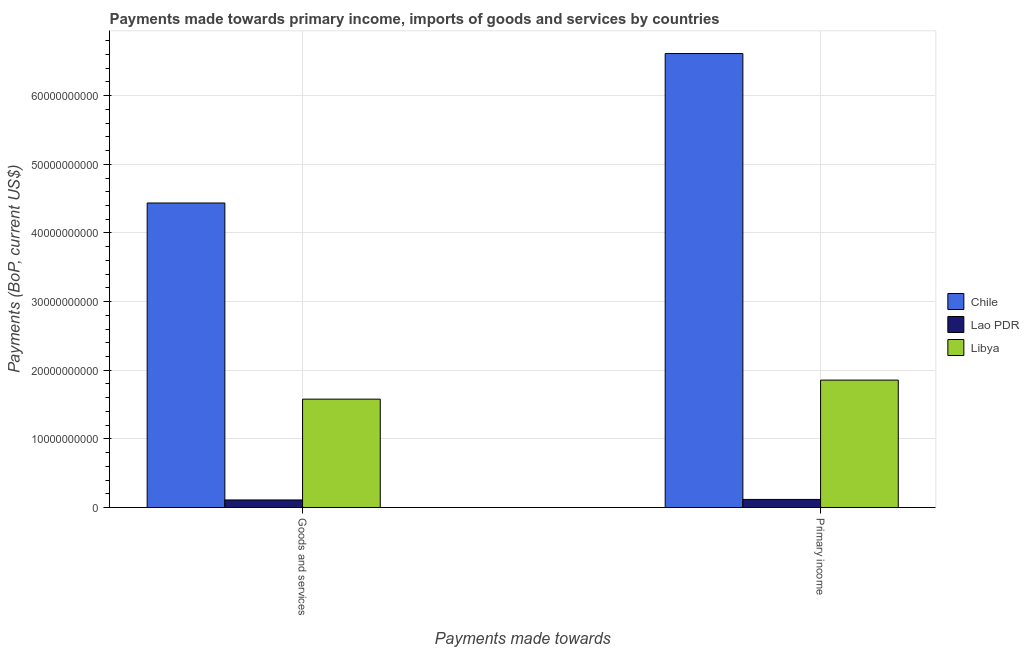How many different coloured bars are there?
Provide a succinct answer. 3. How many groups of bars are there?
Provide a succinct answer. 2. Are the number of bars per tick equal to the number of legend labels?
Give a very brief answer. Yes. What is the label of the 2nd group of bars from the left?
Offer a terse response. Primary income. What is the payments made towards goods and services in Lao PDR?
Offer a very short reply. 1.10e+09. Across all countries, what is the maximum payments made towards goods and services?
Offer a very short reply. 4.44e+1. Across all countries, what is the minimum payments made towards goods and services?
Provide a short and direct response. 1.10e+09. In which country was the payments made towards primary income minimum?
Keep it short and to the point. Lao PDR. What is the total payments made towards primary income in the graph?
Provide a short and direct response. 8.59e+1. What is the difference between the payments made towards primary income in Libya and that in Lao PDR?
Offer a very short reply. 1.74e+1. What is the difference between the payments made towards goods and services in Libya and the payments made towards primary income in Lao PDR?
Your answer should be very brief. 1.46e+1. What is the average payments made towards primary income per country?
Your answer should be very brief. 2.86e+1. What is the difference between the payments made towards goods and services and payments made towards primary income in Libya?
Ensure brevity in your answer.  -2.78e+09. What is the ratio of the payments made towards goods and services in Lao PDR to that in Libya?
Provide a succinct answer. 0.07. In how many countries, is the payments made towards primary income greater than the average payments made towards primary income taken over all countries?
Your answer should be compact. 1. What does the 1st bar from the left in Goods and services represents?
Offer a terse response. Chile. How many bars are there?
Provide a short and direct response. 6. Are all the bars in the graph horizontal?
Your answer should be very brief. No. Are the values on the major ticks of Y-axis written in scientific E-notation?
Make the answer very short. No. How many legend labels are there?
Your answer should be compact. 3. How are the legend labels stacked?
Your answer should be very brief. Vertical. What is the title of the graph?
Give a very brief answer. Payments made towards primary income, imports of goods and services by countries. What is the label or title of the X-axis?
Your answer should be very brief. Payments made towards. What is the label or title of the Y-axis?
Give a very brief answer. Payments (BoP, current US$). What is the Payments (BoP, current US$) in Chile in Goods and services?
Your answer should be compact. 4.44e+1. What is the Payments (BoP, current US$) in Lao PDR in Goods and services?
Ensure brevity in your answer.  1.10e+09. What is the Payments (BoP, current US$) of Libya in Goods and services?
Your response must be concise. 1.58e+1. What is the Payments (BoP, current US$) in Chile in Primary income?
Offer a very short reply. 6.61e+1. What is the Payments (BoP, current US$) of Lao PDR in Primary income?
Give a very brief answer. 1.17e+09. What is the Payments (BoP, current US$) of Libya in Primary income?
Provide a succinct answer. 1.86e+1. Across all Payments made towards, what is the maximum Payments (BoP, current US$) in Chile?
Provide a succinct answer. 6.61e+1. Across all Payments made towards, what is the maximum Payments (BoP, current US$) in Lao PDR?
Ensure brevity in your answer.  1.17e+09. Across all Payments made towards, what is the maximum Payments (BoP, current US$) of Libya?
Offer a terse response. 1.86e+1. Across all Payments made towards, what is the minimum Payments (BoP, current US$) of Chile?
Keep it short and to the point. 4.44e+1. Across all Payments made towards, what is the minimum Payments (BoP, current US$) of Lao PDR?
Your response must be concise. 1.10e+09. Across all Payments made towards, what is the minimum Payments (BoP, current US$) in Libya?
Provide a short and direct response. 1.58e+1. What is the total Payments (BoP, current US$) of Chile in the graph?
Provide a succinct answer. 1.10e+11. What is the total Payments (BoP, current US$) in Lao PDR in the graph?
Provide a short and direct response. 2.27e+09. What is the total Payments (BoP, current US$) of Libya in the graph?
Ensure brevity in your answer.  3.43e+1. What is the difference between the Payments (BoP, current US$) of Chile in Goods and services and that in Primary income?
Offer a very short reply. -2.18e+1. What is the difference between the Payments (BoP, current US$) in Lao PDR in Goods and services and that in Primary income?
Offer a very short reply. -7.54e+07. What is the difference between the Payments (BoP, current US$) of Libya in Goods and services and that in Primary income?
Give a very brief answer. -2.78e+09. What is the difference between the Payments (BoP, current US$) of Chile in Goods and services and the Payments (BoP, current US$) of Lao PDR in Primary income?
Provide a succinct answer. 4.32e+1. What is the difference between the Payments (BoP, current US$) of Chile in Goods and services and the Payments (BoP, current US$) of Libya in Primary income?
Provide a short and direct response. 2.58e+1. What is the difference between the Payments (BoP, current US$) in Lao PDR in Goods and services and the Payments (BoP, current US$) in Libya in Primary income?
Make the answer very short. -1.75e+1. What is the average Payments (BoP, current US$) of Chile per Payments made towards?
Give a very brief answer. 5.52e+1. What is the average Payments (BoP, current US$) in Lao PDR per Payments made towards?
Keep it short and to the point. 1.14e+09. What is the average Payments (BoP, current US$) of Libya per Payments made towards?
Ensure brevity in your answer.  1.72e+1. What is the difference between the Payments (BoP, current US$) of Chile and Payments (BoP, current US$) of Lao PDR in Goods and services?
Offer a very short reply. 4.33e+1. What is the difference between the Payments (BoP, current US$) in Chile and Payments (BoP, current US$) in Libya in Goods and services?
Your response must be concise. 2.86e+1. What is the difference between the Payments (BoP, current US$) in Lao PDR and Payments (BoP, current US$) in Libya in Goods and services?
Offer a very short reply. -1.47e+1. What is the difference between the Payments (BoP, current US$) of Chile and Payments (BoP, current US$) of Lao PDR in Primary income?
Give a very brief answer. 6.50e+1. What is the difference between the Payments (BoP, current US$) of Chile and Payments (BoP, current US$) of Libya in Primary income?
Offer a very short reply. 4.76e+1. What is the difference between the Payments (BoP, current US$) in Lao PDR and Payments (BoP, current US$) in Libya in Primary income?
Give a very brief answer. -1.74e+1. What is the ratio of the Payments (BoP, current US$) in Chile in Goods and services to that in Primary income?
Offer a very short reply. 0.67. What is the ratio of the Payments (BoP, current US$) in Lao PDR in Goods and services to that in Primary income?
Your answer should be very brief. 0.94. What is the ratio of the Payments (BoP, current US$) in Libya in Goods and services to that in Primary income?
Give a very brief answer. 0.85. What is the difference between the highest and the second highest Payments (BoP, current US$) of Chile?
Provide a succinct answer. 2.18e+1. What is the difference between the highest and the second highest Payments (BoP, current US$) of Lao PDR?
Keep it short and to the point. 7.54e+07. What is the difference between the highest and the second highest Payments (BoP, current US$) of Libya?
Give a very brief answer. 2.78e+09. What is the difference between the highest and the lowest Payments (BoP, current US$) of Chile?
Offer a very short reply. 2.18e+1. What is the difference between the highest and the lowest Payments (BoP, current US$) in Lao PDR?
Provide a short and direct response. 7.54e+07. What is the difference between the highest and the lowest Payments (BoP, current US$) in Libya?
Keep it short and to the point. 2.78e+09. 